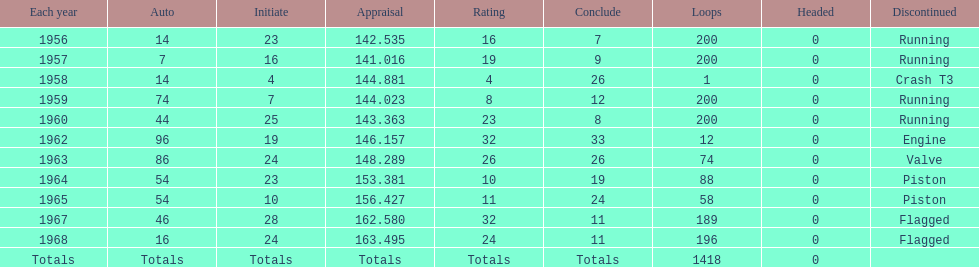Tell me the number of times he finished above 10th place. 3. 